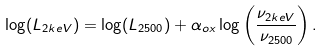Convert formula to latex. <formula><loc_0><loc_0><loc_500><loc_500>\log ( L _ { 2 k e V } ) = \log ( L _ { 2 5 0 0 } ) + \alpha _ { o x } \log \left ( \frac { \nu _ { 2 k e V } } { \nu _ { 2 5 0 0 } } \right ) .</formula> 